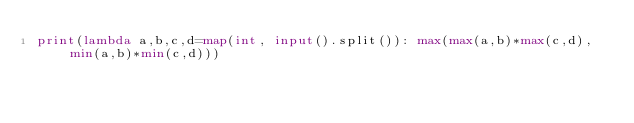<code> <loc_0><loc_0><loc_500><loc_500><_Python_>print(lambda a,b,c,d=map(int, input().split()): max(max(a,b)*max(c,d), min(a,b)*min(c,d)))</code> 